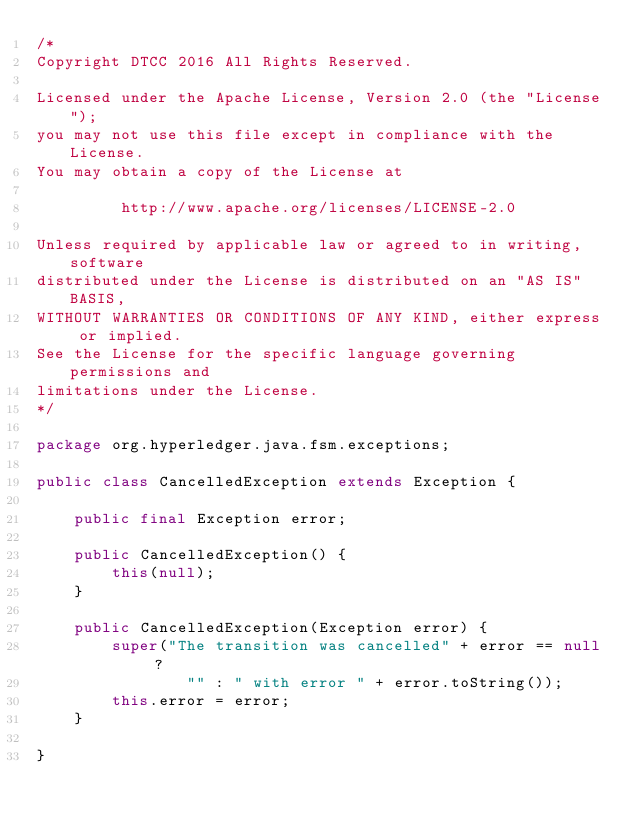<code> <loc_0><loc_0><loc_500><loc_500><_Java_>/*
Copyright DTCC 2016 All Rights Reserved.

Licensed under the Apache License, Version 2.0 (the "License");
you may not use this file except in compliance with the License.
You may obtain a copy of the License at

         http://www.apache.org/licenses/LICENSE-2.0

Unless required by applicable law or agreed to in writing, software
distributed under the License is distributed on an "AS IS" BASIS,
WITHOUT WARRANTIES OR CONDITIONS OF ANY KIND, either express or implied.
See the License for the specific language governing permissions and
limitations under the License.
*/

package org.hyperledger.java.fsm.exceptions;

public class CancelledException extends Exception {

	public final Exception error;
	
	public CancelledException() {
		this(null);
	}
	
	public CancelledException(Exception error) {
		super("The transition was cancelled" + error == null ?
				"" : " with error " + error.toString());
		this.error = error;
	}
	
}
</code> 